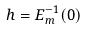<formula> <loc_0><loc_0><loc_500><loc_500>h = E _ { m } ^ { - 1 } ( 0 )</formula> 